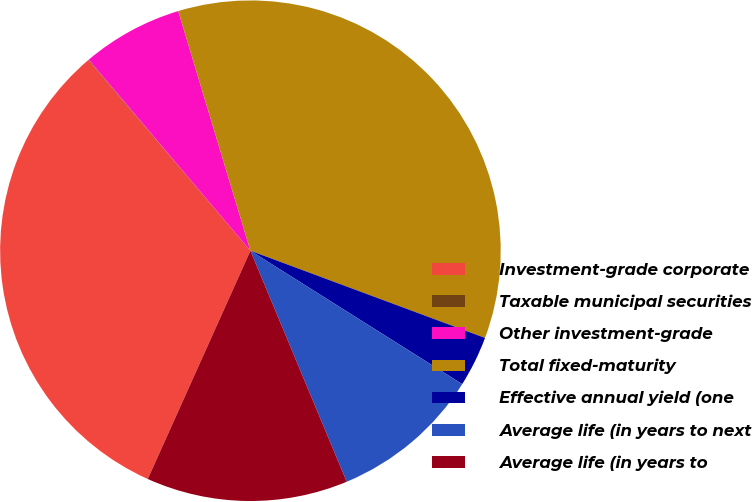<chart> <loc_0><loc_0><loc_500><loc_500><pie_chart><fcel>Investment-grade corporate<fcel>Taxable municipal securities<fcel>Other investment-grade<fcel>Total fixed-maturity<fcel>Effective annual yield (one<fcel>Average life (in years to next<fcel>Average life (in years to<nl><fcel>32.07%<fcel>0.03%<fcel>6.52%<fcel>35.32%<fcel>3.28%<fcel>9.77%<fcel>13.01%<nl></chart> 